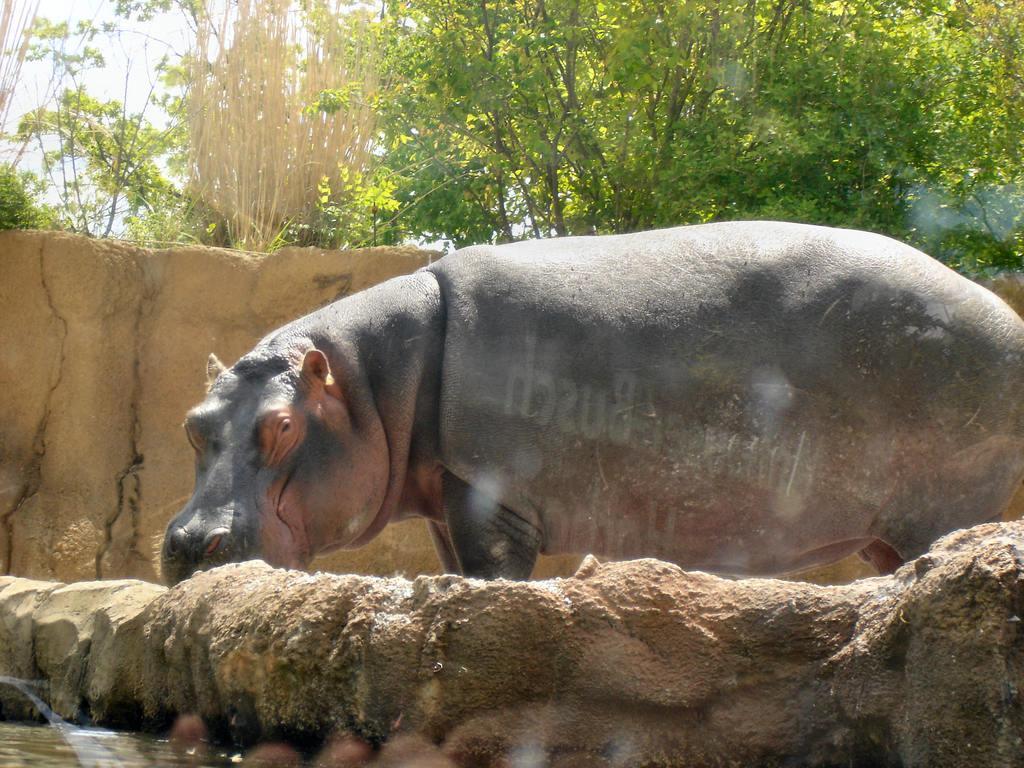In one or two sentences, can you explain what this image depicts? In this picture we can see a hippopotamus standing, at the left bottom there is water, we can see trees in the background. 